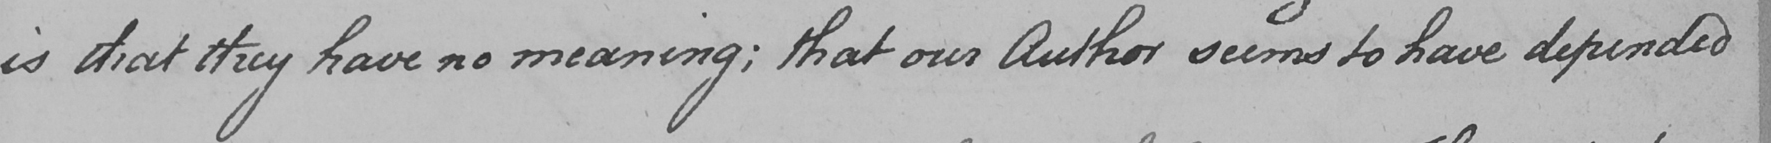What does this handwritten line say? is that they have no meaning ; that our Author seems to have depended 